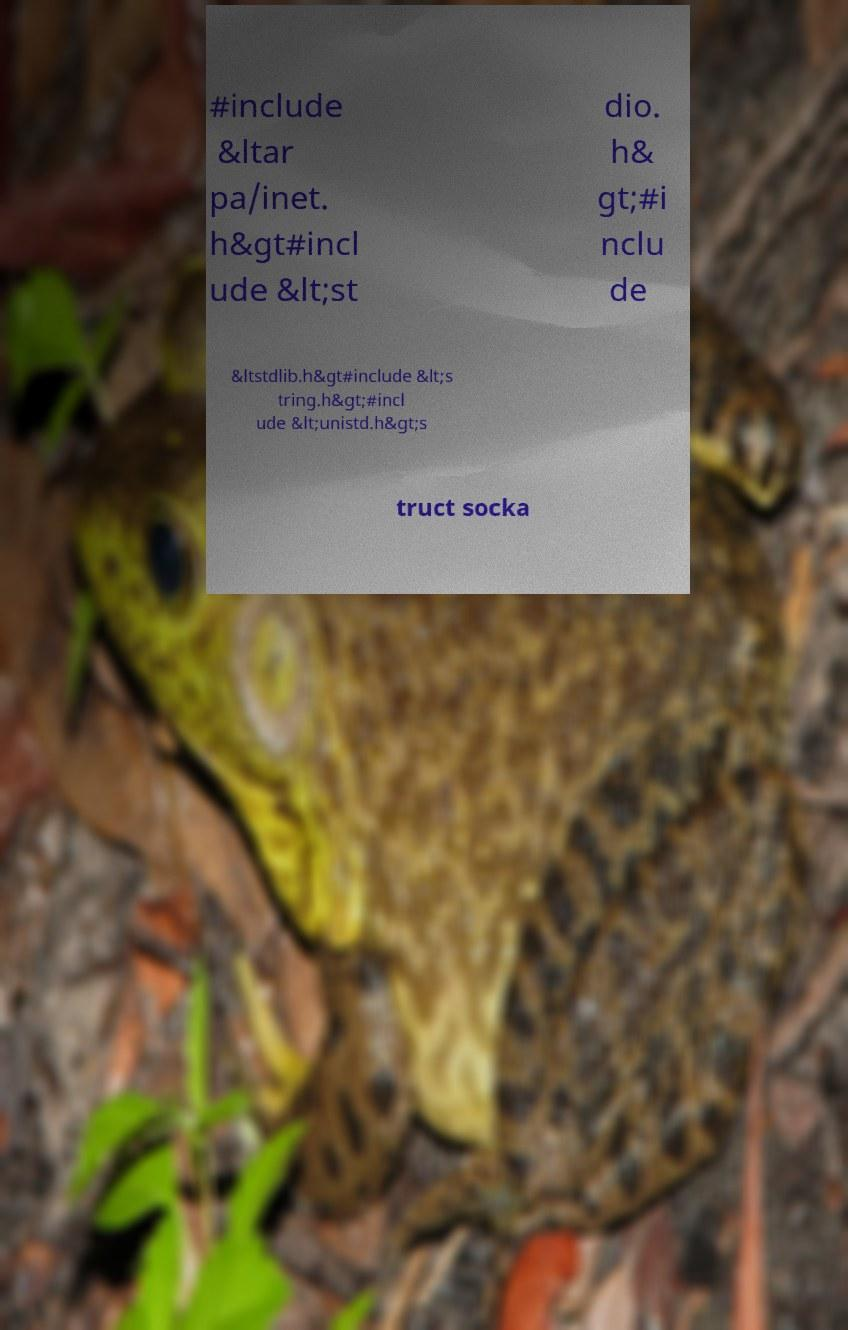I need the written content from this picture converted into text. Can you do that? #include &ltar pa/inet. h&gt#incl ude &lt;st dio. h& gt;#i nclu de &ltstdlib.h&gt#include &lt;s tring.h&gt;#incl ude &lt;unistd.h&gt;s truct socka 